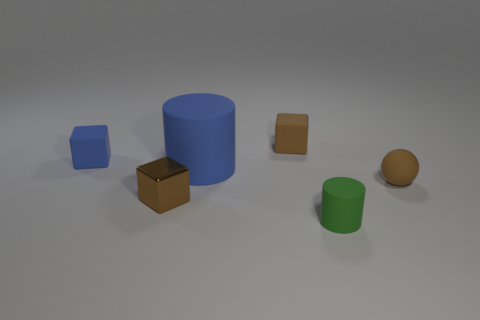Could you describe the colors and shapes of the objects in front of the brown sphere? In front of the brown sphere, there appears to be a blue cylinder and a green cylinder, both with smooth surfaces and distinct cylindrical shapes. 